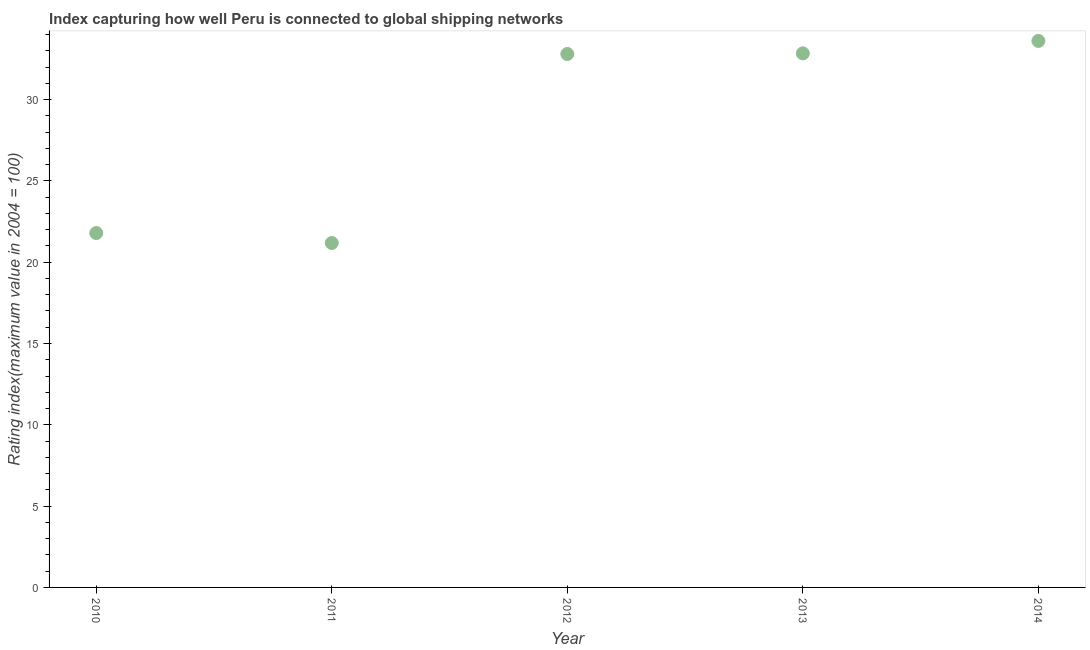What is the liner shipping connectivity index in 2012?
Provide a short and direct response. 32.8. Across all years, what is the maximum liner shipping connectivity index?
Provide a short and direct response. 33.6. Across all years, what is the minimum liner shipping connectivity index?
Keep it short and to the point. 21.18. In which year was the liner shipping connectivity index maximum?
Your answer should be very brief. 2014. In which year was the liner shipping connectivity index minimum?
Provide a succinct answer. 2011. What is the sum of the liner shipping connectivity index?
Keep it short and to the point. 142.21. What is the difference between the liner shipping connectivity index in 2012 and 2014?
Your answer should be compact. -0.8. What is the average liner shipping connectivity index per year?
Offer a very short reply. 28.44. What is the median liner shipping connectivity index?
Offer a very short reply. 32.8. Do a majority of the years between 2013 and 2011 (inclusive) have liner shipping connectivity index greater than 7 ?
Offer a terse response. No. What is the ratio of the liner shipping connectivity index in 2010 to that in 2012?
Your answer should be very brief. 0.66. Is the liner shipping connectivity index in 2012 less than that in 2013?
Provide a succinct answer. Yes. Is the difference between the liner shipping connectivity index in 2010 and 2011 greater than the difference between any two years?
Offer a very short reply. No. What is the difference between the highest and the second highest liner shipping connectivity index?
Your answer should be compact. 0.76. Is the sum of the liner shipping connectivity index in 2011 and 2014 greater than the maximum liner shipping connectivity index across all years?
Your answer should be very brief. Yes. What is the difference between the highest and the lowest liner shipping connectivity index?
Provide a succinct answer. 12.42. Does the liner shipping connectivity index monotonically increase over the years?
Offer a very short reply. No. How many years are there in the graph?
Keep it short and to the point. 5. What is the title of the graph?
Your answer should be compact. Index capturing how well Peru is connected to global shipping networks. What is the label or title of the Y-axis?
Your response must be concise. Rating index(maximum value in 2004 = 100). What is the Rating index(maximum value in 2004 = 100) in 2010?
Your response must be concise. 21.79. What is the Rating index(maximum value in 2004 = 100) in 2011?
Your response must be concise. 21.18. What is the Rating index(maximum value in 2004 = 100) in 2012?
Your answer should be compact. 32.8. What is the Rating index(maximum value in 2004 = 100) in 2013?
Provide a succinct answer. 32.84. What is the Rating index(maximum value in 2004 = 100) in 2014?
Provide a succinct answer. 33.6. What is the difference between the Rating index(maximum value in 2004 = 100) in 2010 and 2011?
Give a very brief answer. 0.61. What is the difference between the Rating index(maximum value in 2004 = 100) in 2010 and 2012?
Your response must be concise. -11.01. What is the difference between the Rating index(maximum value in 2004 = 100) in 2010 and 2013?
Your answer should be compact. -11.05. What is the difference between the Rating index(maximum value in 2004 = 100) in 2010 and 2014?
Your answer should be very brief. -11.81. What is the difference between the Rating index(maximum value in 2004 = 100) in 2011 and 2012?
Give a very brief answer. -11.62. What is the difference between the Rating index(maximum value in 2004 = 100) in 2011 and 2013?
Ensure brevity in your answer.  -11.66. What is the difference between the Rating index(maximum value in 2004 = 100) in 2011 and 2014?
Provide a short and direct response. -12.42. What is the difference between the Rating index(maximum value in 2004 = 100) in 2012 and 2013?
Offer a very short reply. -0.04. What is the difference between the Rating index(maximum value in 2004 = 100) in 2012 and 2014?
Provide a short and direct response. -0.8. What is the difference between the Rating index(maximum value in 2004 = 100) in 2013 and 2014?
Offer a very short reply. -0.76. What is the ratio of the Rating index(maximum value in 2004 = 100) in 2010 to that in 2012?
Keep it short and to the point. 0.66. What is the ratio of the Rating index(maximum value in 2004 = 100) in 2010 to that in 2013?
Provide a short and direct response. 0.66. What is the ratio of the Rating index(maximum value in 2004 = 100) in 2010 to that in 2014?
Your response must be concise. 0.65. What is the ratio of the Rating index(maximum value in 2004 = 100) in 2011 to that in 2012?
Your answer should be compact. 0.65. What is the ratio of the Rating index(maximum value in 2004 = 100) in 2011 to that in 2013?
Your response must be concise. 0.65. What is the ratio of the Rating index(maximum value in 2004 = 100) in 2011 to that in 2014?
Give a very brief answer. 0.63. What is the ratio of the Rating index(maximum value in 2004 = 100) in 2012 to that in 2013?
Keep it short and to the point. 1. What is the ratio of the Rating index(maximum value in 2004 = 100) in 2012 to that in 2014?
Provide a short and direct response. 0.98. What is the ratio of the Rating index(maximum value in 2004 = 100) in 2013 to that in 2014?
Your response must be concise. 0.98. 